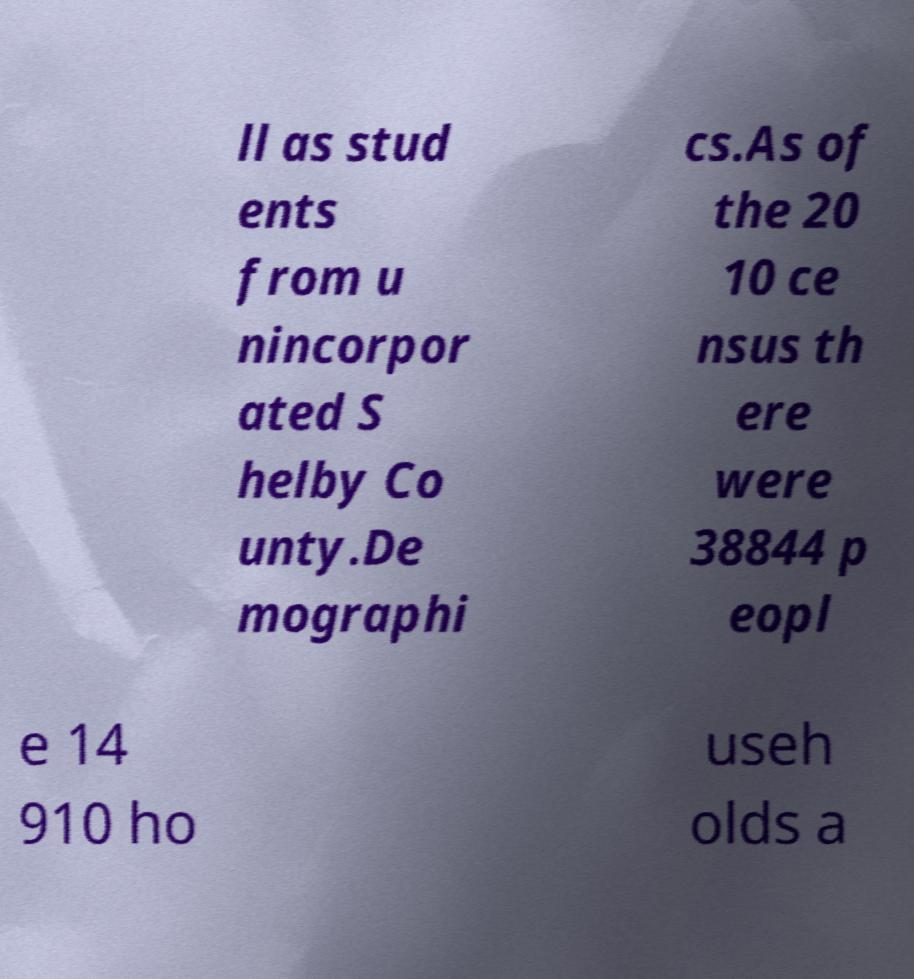Can you accurately transcribe the text from the provided image for me? ll as stud ents from u nincorpor ated S helby Co unty.De mographi cs.As of the 20 10 ce nsus th ere were 38844 p eopl e 14 910 ho useh olds a 